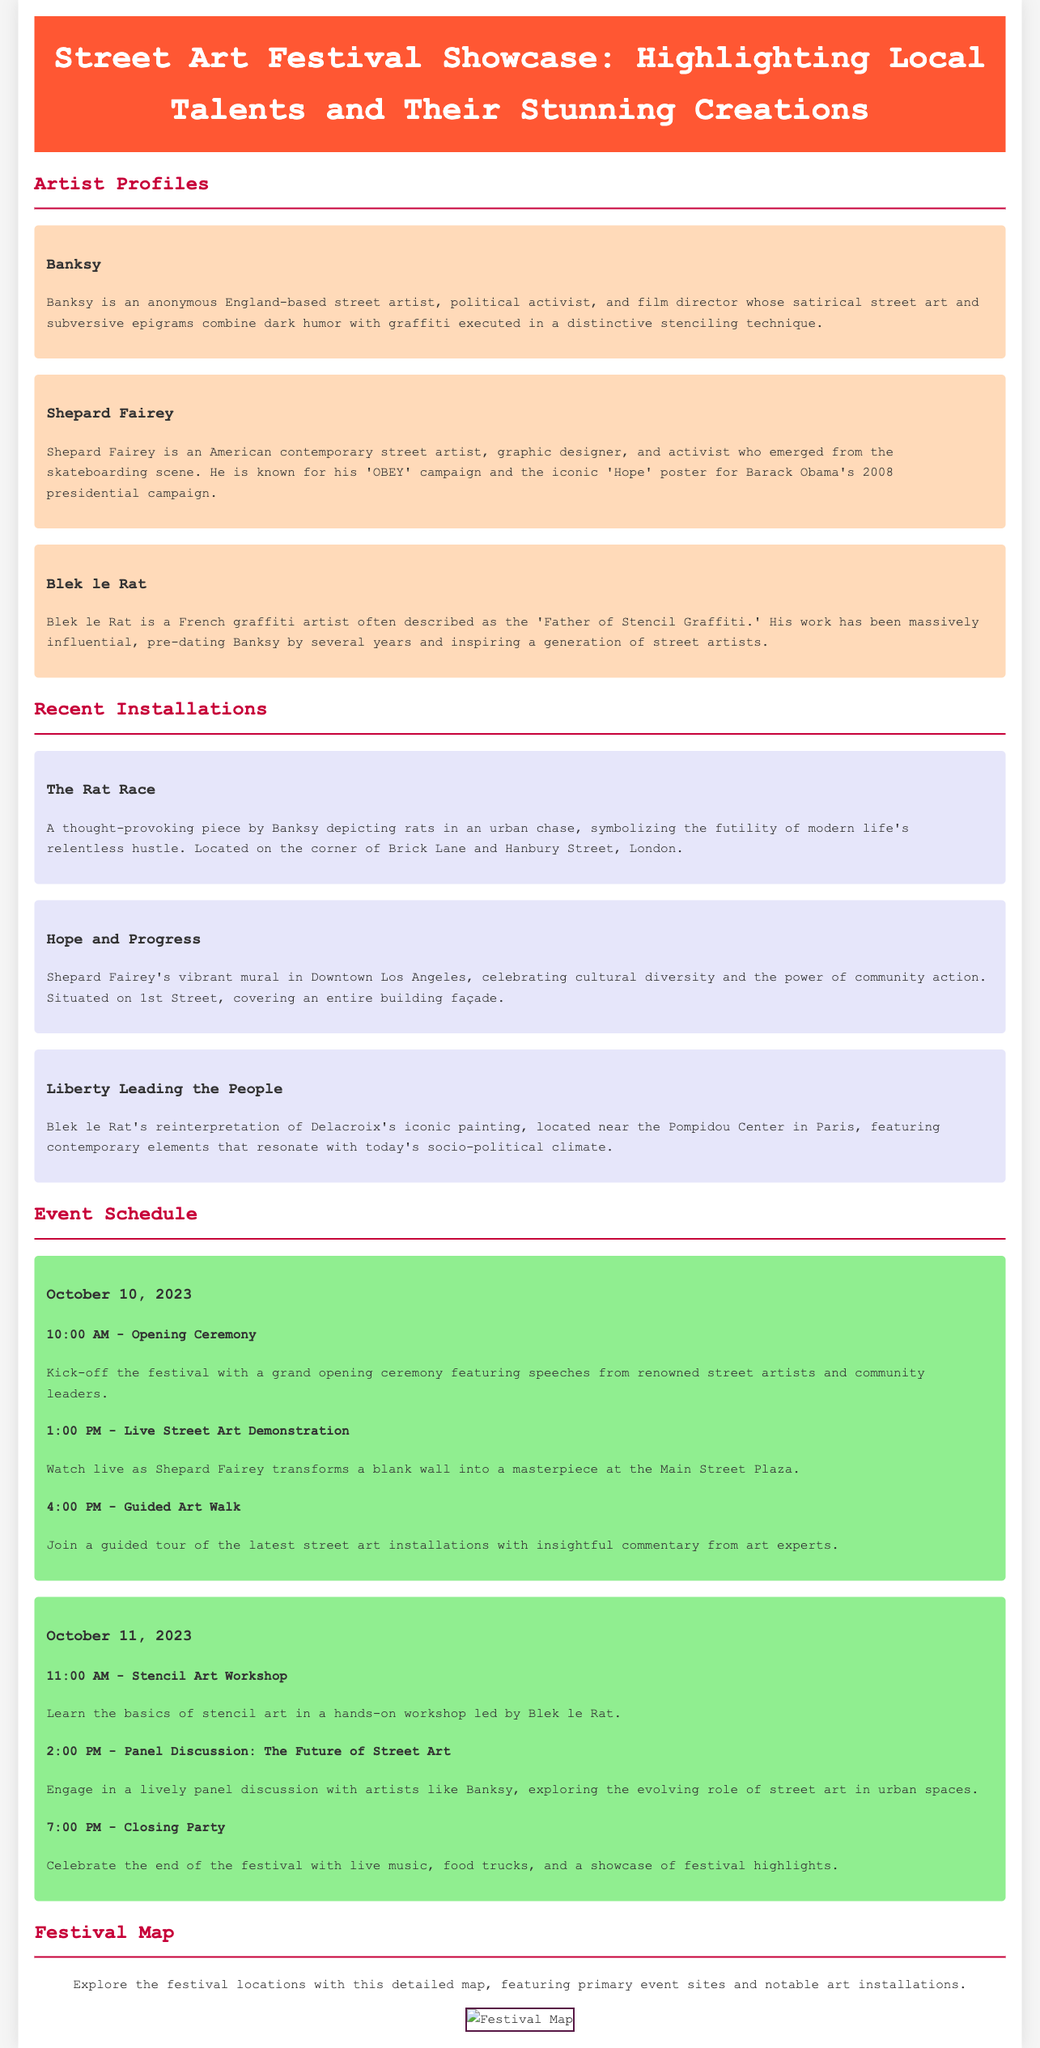what is the title of the event? The title of the event is found in the header section of the document.
Answer: Street Art Festival Showcase: Highlighting Local Talents and Their Stunning Creations who is the artist known for the 'OBEY' campaign? The artist's name is mentioned in the artist profiles section.
Answer: Shepard Fairey what is the location of Banksy's installation titled "The Rat Race"? The location is provided in the description of the installation.
Answer: the corner of Brick Lane and Hanbury Street, London which date features a Stencil Art Workshop? The date is mentioned in the event schedule for the workshop.
Answer: October 11, 2023 what color is used for the event day section? The background color for the event day section is described in the style section of the document.
Answer: light green how many artists are profiled in the document? The number of artist profiles can be found in the Artist Profiles section.
Answer: three where is Shepard Fairey's mural located? The location of the mural is mentioned in the description of the recent installation.
Answer: 1st Street, Downtown Los Angeles what activity starts the festival on October 10, 2023? The activity is listed in the event schedule under the first event.
Answer: Opening Ceremony which installation is a reinterpretation of Delacroix's painting? The installation title can be found in the description of one of the recent installations.
Answer: Liberty Leading the People 